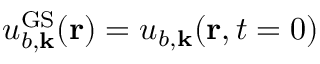Convert formula to latex. <formula><loc_0><loc_0><loc_500><loc_500>u _ { b , { k } } ^ { G S } ( { r } ) = u _ { b , { k } } ( { r } , t = 0 )</formula> 